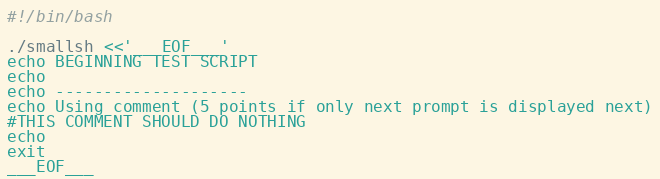<code> <loc_0><loc_0><loc_500><loc_500><_Bash_>#!/bin/bash

./smallsh <<'___EOF___'
echo BEGINNING TEST SCRIPT
echo
echo --------------------
echo Using comment (5 points if only next prompt is displayed next)
#THIS COMMENT SHOULD DO NOTHING
echo
exit
___EOF___
</code> 